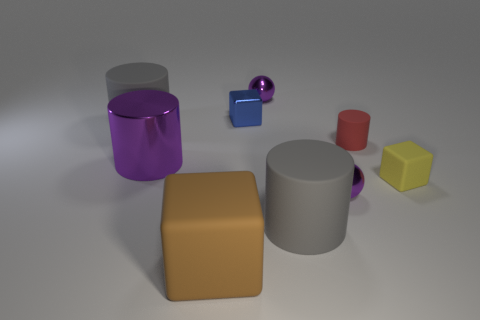Subtract all matte cylinders. How many cylinders are left? 1 Subtract all yellow blocks. How many blocks are left? 2 Subtract all brown blocks. How many gray cylinders are left? 2 Add 1 big red cylinders. How many objects exist? 10 Subtract 1 cylinders. How many cylinders are left? 3 Subtract all spheres. How many objects are left? 7 Subtract all big purple things. Subtract all tiny blue objects. How many objects are left? 7 Add 7 tiny balls. How many tiny balls are left? 9 Add 7 yellow rubber cylinders. How many yellow rubber cylinders exist? 7 Subtract 2 gray cylinders. How many objects are left? 7 